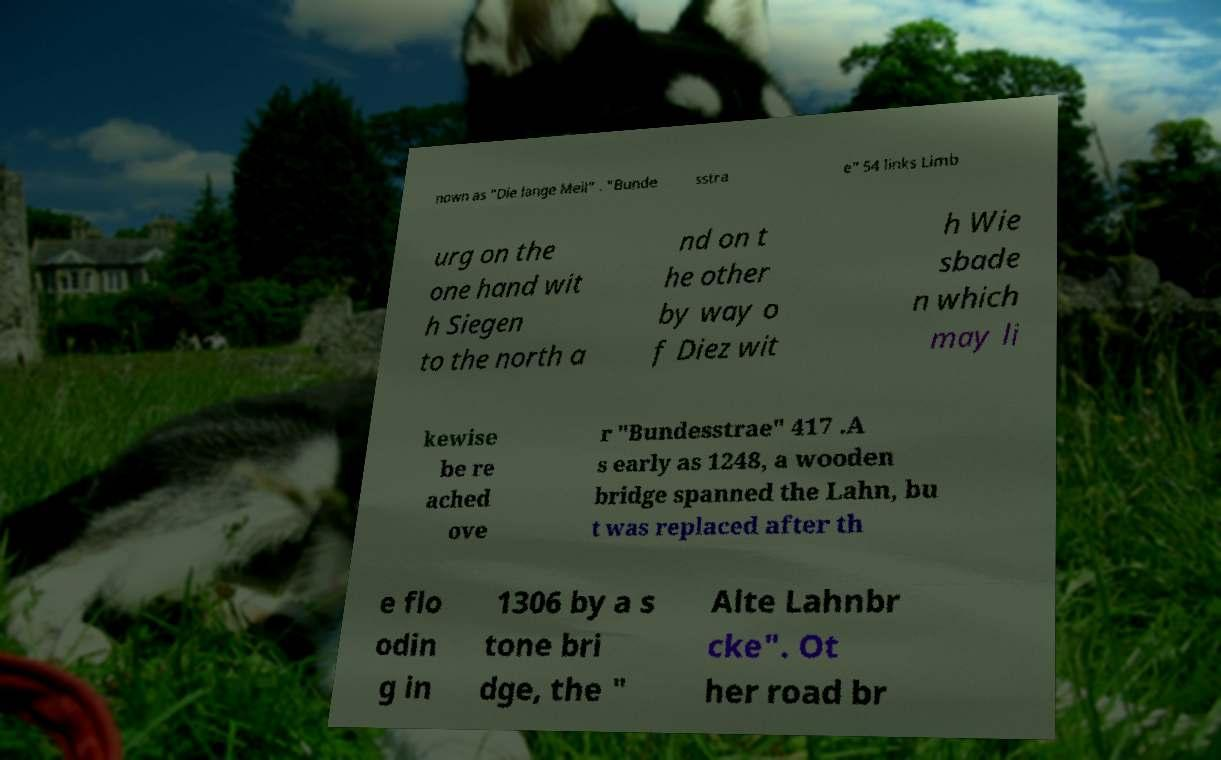Could you assist in decoding the text presented in this image and type it out clearly? nown as "Die lange Meil" . "Bunde sstra e" 54 links Limb urg on the one hand wit h Siegen to the north a nd on t he other by way o f Diez wit h Wie sbade n which may li kewise be re ached ove r "Bundesstrae" 417 .A s early as 1248, a wooden bridge spanned the Lahn, bu t was replaced after th e flo odin g in 1306 by a s tone bri dge, the " Alte Lahnbr cke". Ot her road br 